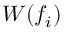Convert formula to latex. <formula><loc_0><loc_0><loc_500><loc_500>W ( f _ { i } )</formula> 